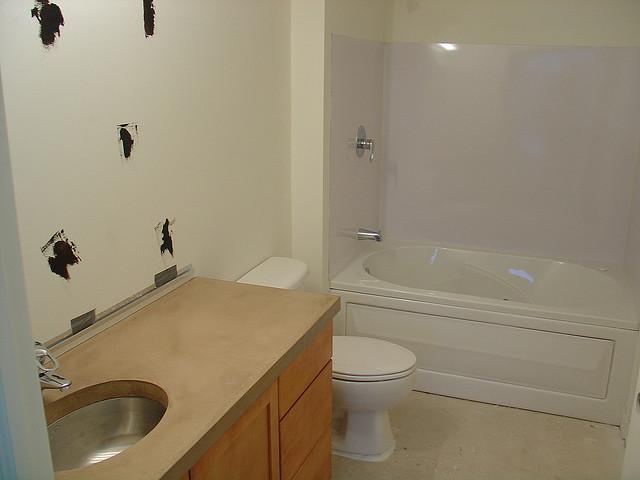Are there two shower curtains?
Give a very brief answer. No. Is this handicap friendly?
Concise answer only. No. What is the floor made of?
Write a very short answer. Tile. Is there a mirror on the wall?
Quick response, please. No. What is the only colorful item in this picture?
Quick response, please. Wall. Is there a mirror in this bathroom?
Give a very brief answer. No. Is this bathroom clean?
Keep it brief. Yes. What is countertop color?
Write a very short answer. Brown. What color is the floor?
Answer briefly. Tan. What is the color of the sink?
Give a very brief answer. Silver. Is the sink bowl clean?
Quick response, please. Yes. What is on the wall being used as decoration?
Be succinct. Nothing. What do people do in here?
Write a very short answer. Shower. Are there jets in the tub?
Quick response, please. No. Is this the kitchen?
Give a very brief answer. No. What color is the sink?
Quick response, please. Silver. How many mirrors?
Short answer required. 0. 